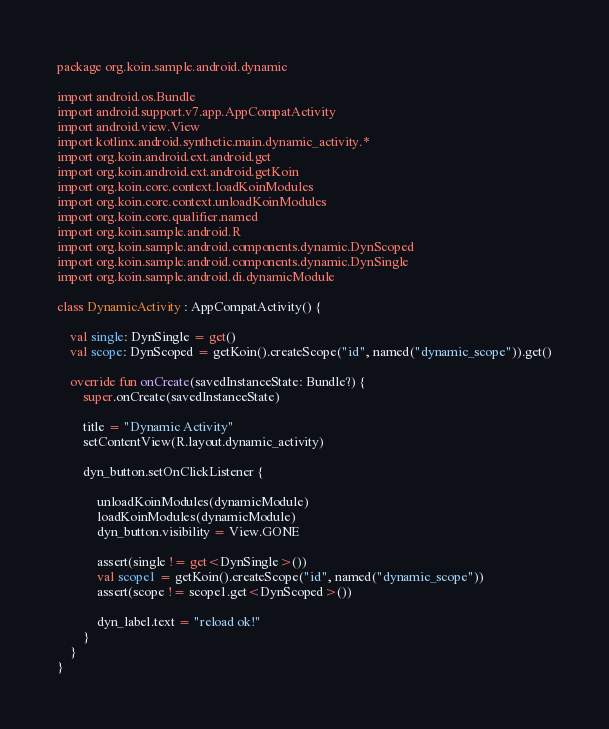Convert code to text. <code><loc_0><loc_0><loc_500><loc_500><_Kotlin_>package org.koin.sample.android.dynamic

import android.os.Bundle
import android.support.v7.app.AppCompatActivity
import android.view.View
import kotlinx.android.synthetic.main.dynamic_activity.*
import org.koin.android.ext.android.get
import org.koin.android.ext.android.getKoin
import org.koin.core.context.loadKoinModules
import org.koin.core.context.unloadKoinModules
import org.koin.core.qualifier.named
import org.koin.sample.android.R
import org.koin.sample.android.components.dynamic.DynScoped
import org.koin.sample.android.components.dynamic.DynSingle
import org.koin.sample.android.di.dynamicModule

class DynamicActivity : AppCompatActivity() {

    val single: DynSingle = get()
    val scope: DynScoped = getKoin().createScope("id", named("dynamic_scope")).get()

    override fun onCreate(savedInstanceState: Bundle?) {
        super.onCreate(savedInstanceState)

        title = "Dynamic Activity"
        setContentView(R.layout.dynamic_activity)

        dyn_button.setOnClickListener {

            unloadKoinModules(dynamicModule)
            loadKoinModules(dynamicModule)
            dyn_button.visibility = View.GONE

            assert(single != get<DynSingle>())
            val scope1 = getKoin().createScope("id", named("dynamic_scope"))
            assert(scope != scope1.get<DynScoped>())

            dyn_label.text = "reload ok!"
        }
    }
}
</code> 